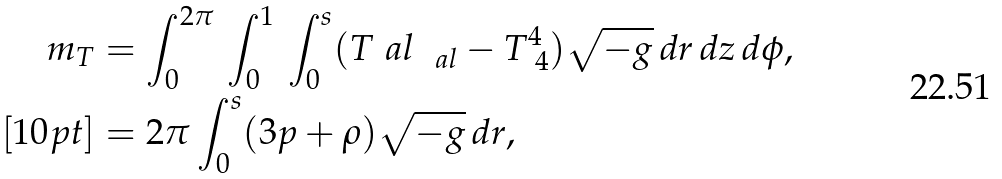Convert formula to latex. <formula><loc_0><loc_0><loc_500><loc_500>m _ { T } & = \int _ { 0 } ^ { 2 \pi } \, \int _ { 0 } ^ { 1 } \, \int ^ { s } _ { 0 } ( T ^ { \ } a l _ { \ \ a l } - T ^ { 4 } _ { \ 4 } ) \sqrt { - g } \, d r \, d z \, d \phi , \\ [ 1 0 p t ] & = 2 \pi \int ^ { s } _ { 0 } ( 3 p + \rho ) \sqrt { - g } \, d r ,</formula> 